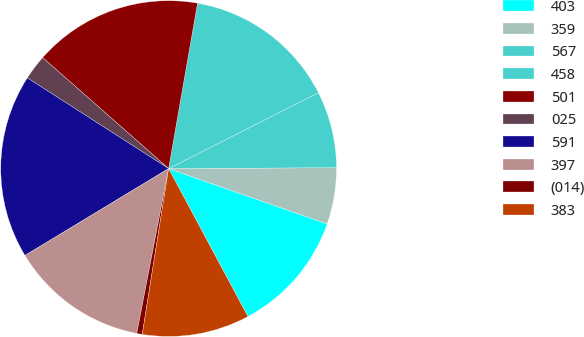<chart> <loc_0><loc_0><loc_500><loc_500><pie_chart><fcel>403<fcel>359<fcel>567<fcel>458<fcel>501<fcel>025<fcel>591<fcel>397<fcel>(014)<fcel>383<nl><fcel>11.82%<fcel>5.43%<fcel>7.38%<fcel>14.78%<fcel>16.26%<fcel>2.41%<fcel>17.74%<fcel>13.3%<fcel>0.53%<fcel>10.34%<nl></chart> 